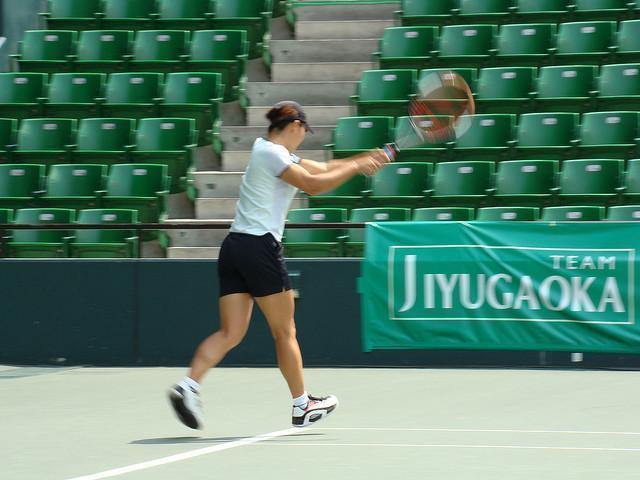What person played a similar sport to this person?
Answer the question by selecting the correct answer among the 4 following choices and explain your choice with a short sentence. The answer should be formatted with the following format: `Answer: choice
Rationale: rationale.`
Options: Alex morgan, bo jackson, jim kelly, martina navratilova. Answer: martina navratilova.
Rationale: The person is playing tennis and martina navratilova played tennis as well. 